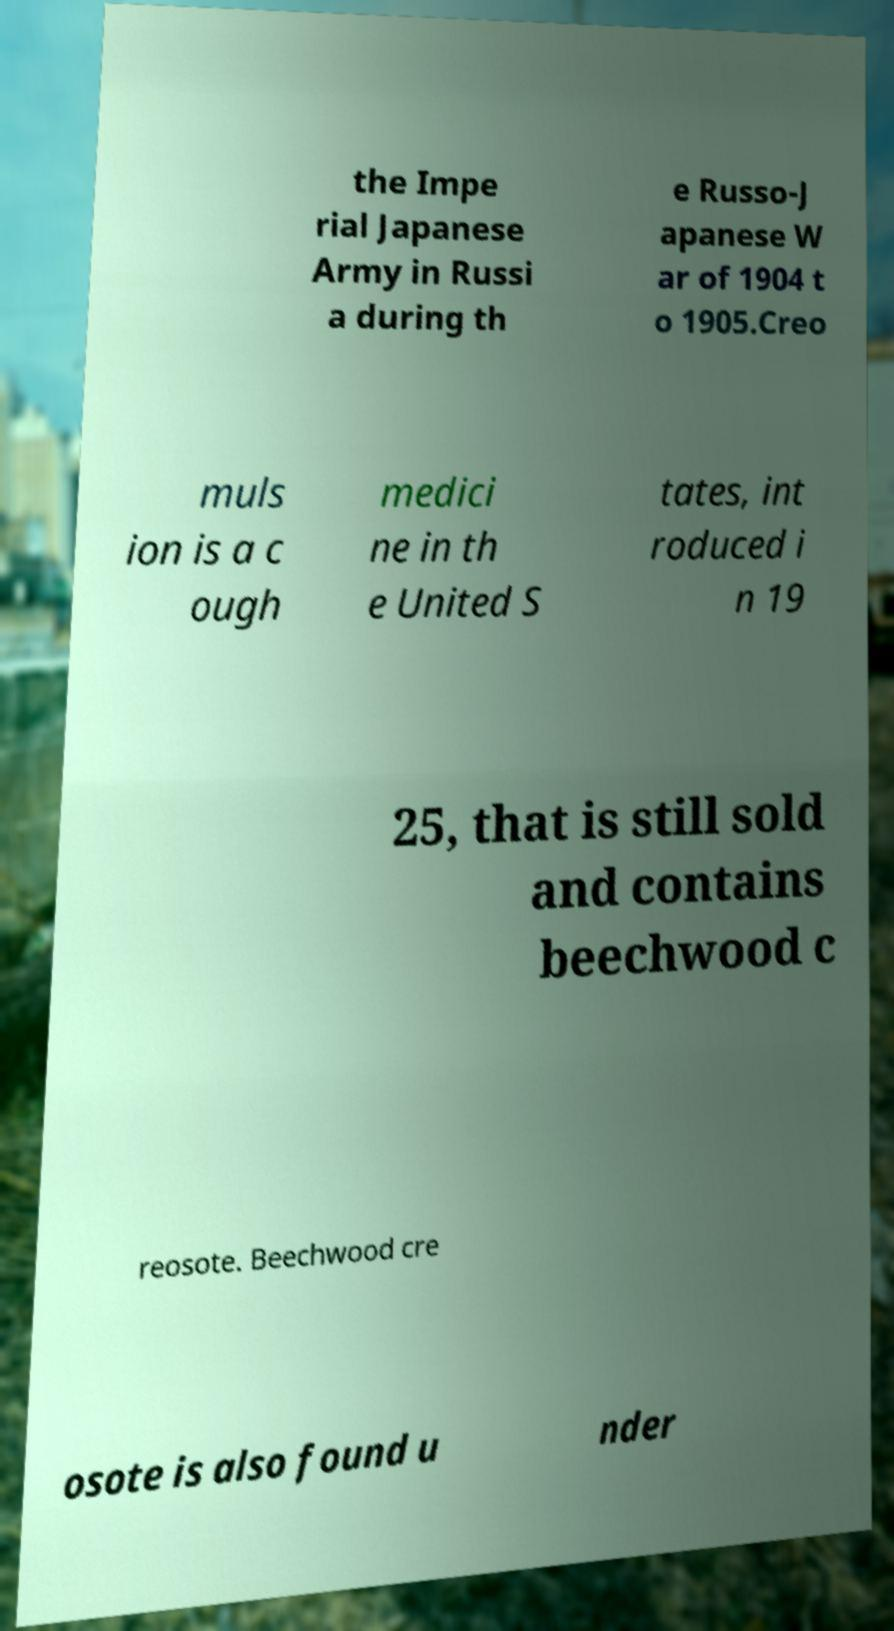There's text embedded in this image that I need extracted. Can you transcribe it verbatim? the Impe rial Japanese Army in Russi a during th e Russo-J apanese W ar of 1904 t o 1905.Creo muls ion is a c ough medici ne in th e United S tates, int roduced i n 19 25, that is still sold and contains beechwood c reosote. Beechwood cre osote is also found u nder 